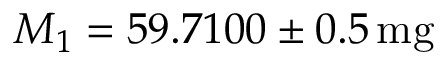Convert formula to latex. <formula><loc_0><loc_0><loc_500><loc_500>M _ { 1 } = 5 9 . 7 1 0 0 \pm 0 . 5 \, m g</formula> 